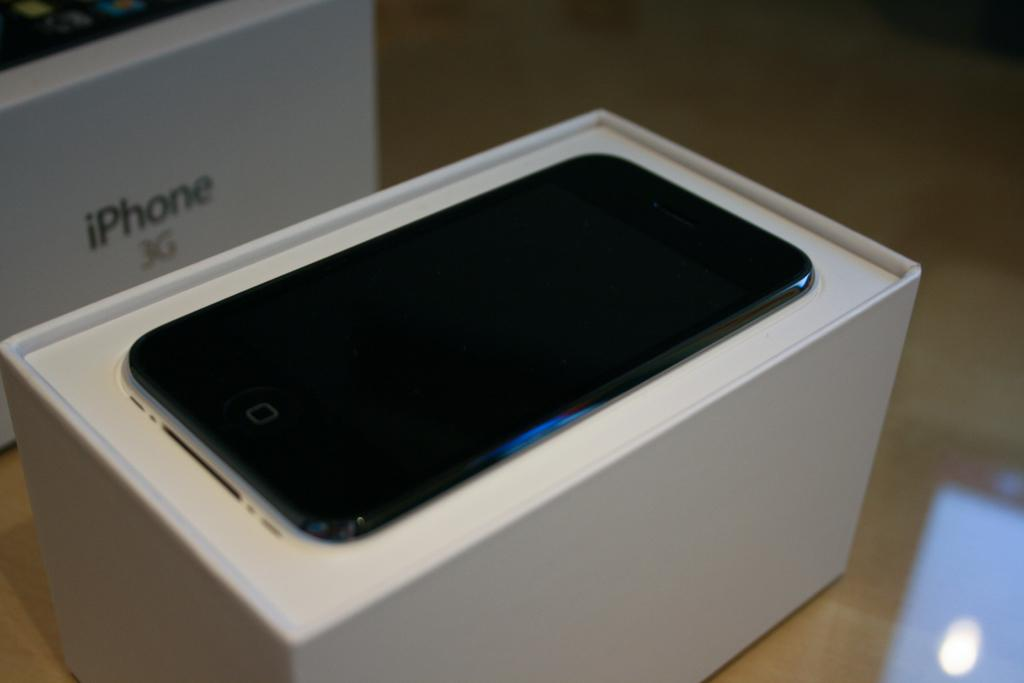<image>
Summarize the visual content of the image. An iphone 3G is displayed in a white box. 